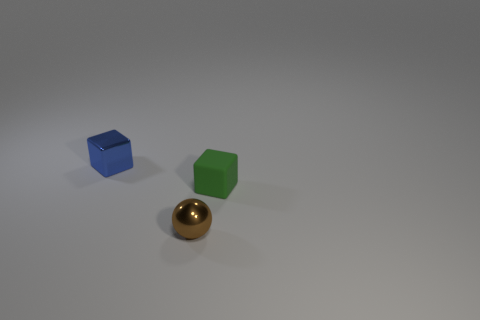Add 3 small brown spheres. How many objects exist? 6 Subtract all balls. How many objects are left? 2 Subtract all small brown shiny balls. Subtract all large red cylinders. How many objects are left? 2 Add 1 brown metallic objects. How many brown metallic objects are left? 2 Add 3 small brown rubber cubes. How many small brown rubber cubes exist? 3 Subtract 1 brown spheres. How many objects are left? 2 